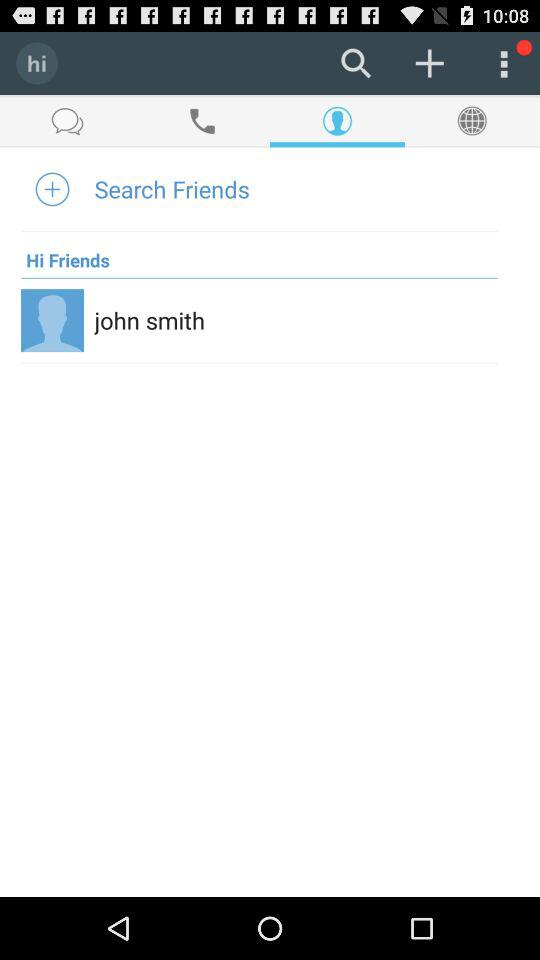What is the user name? The user name is John Smith. 